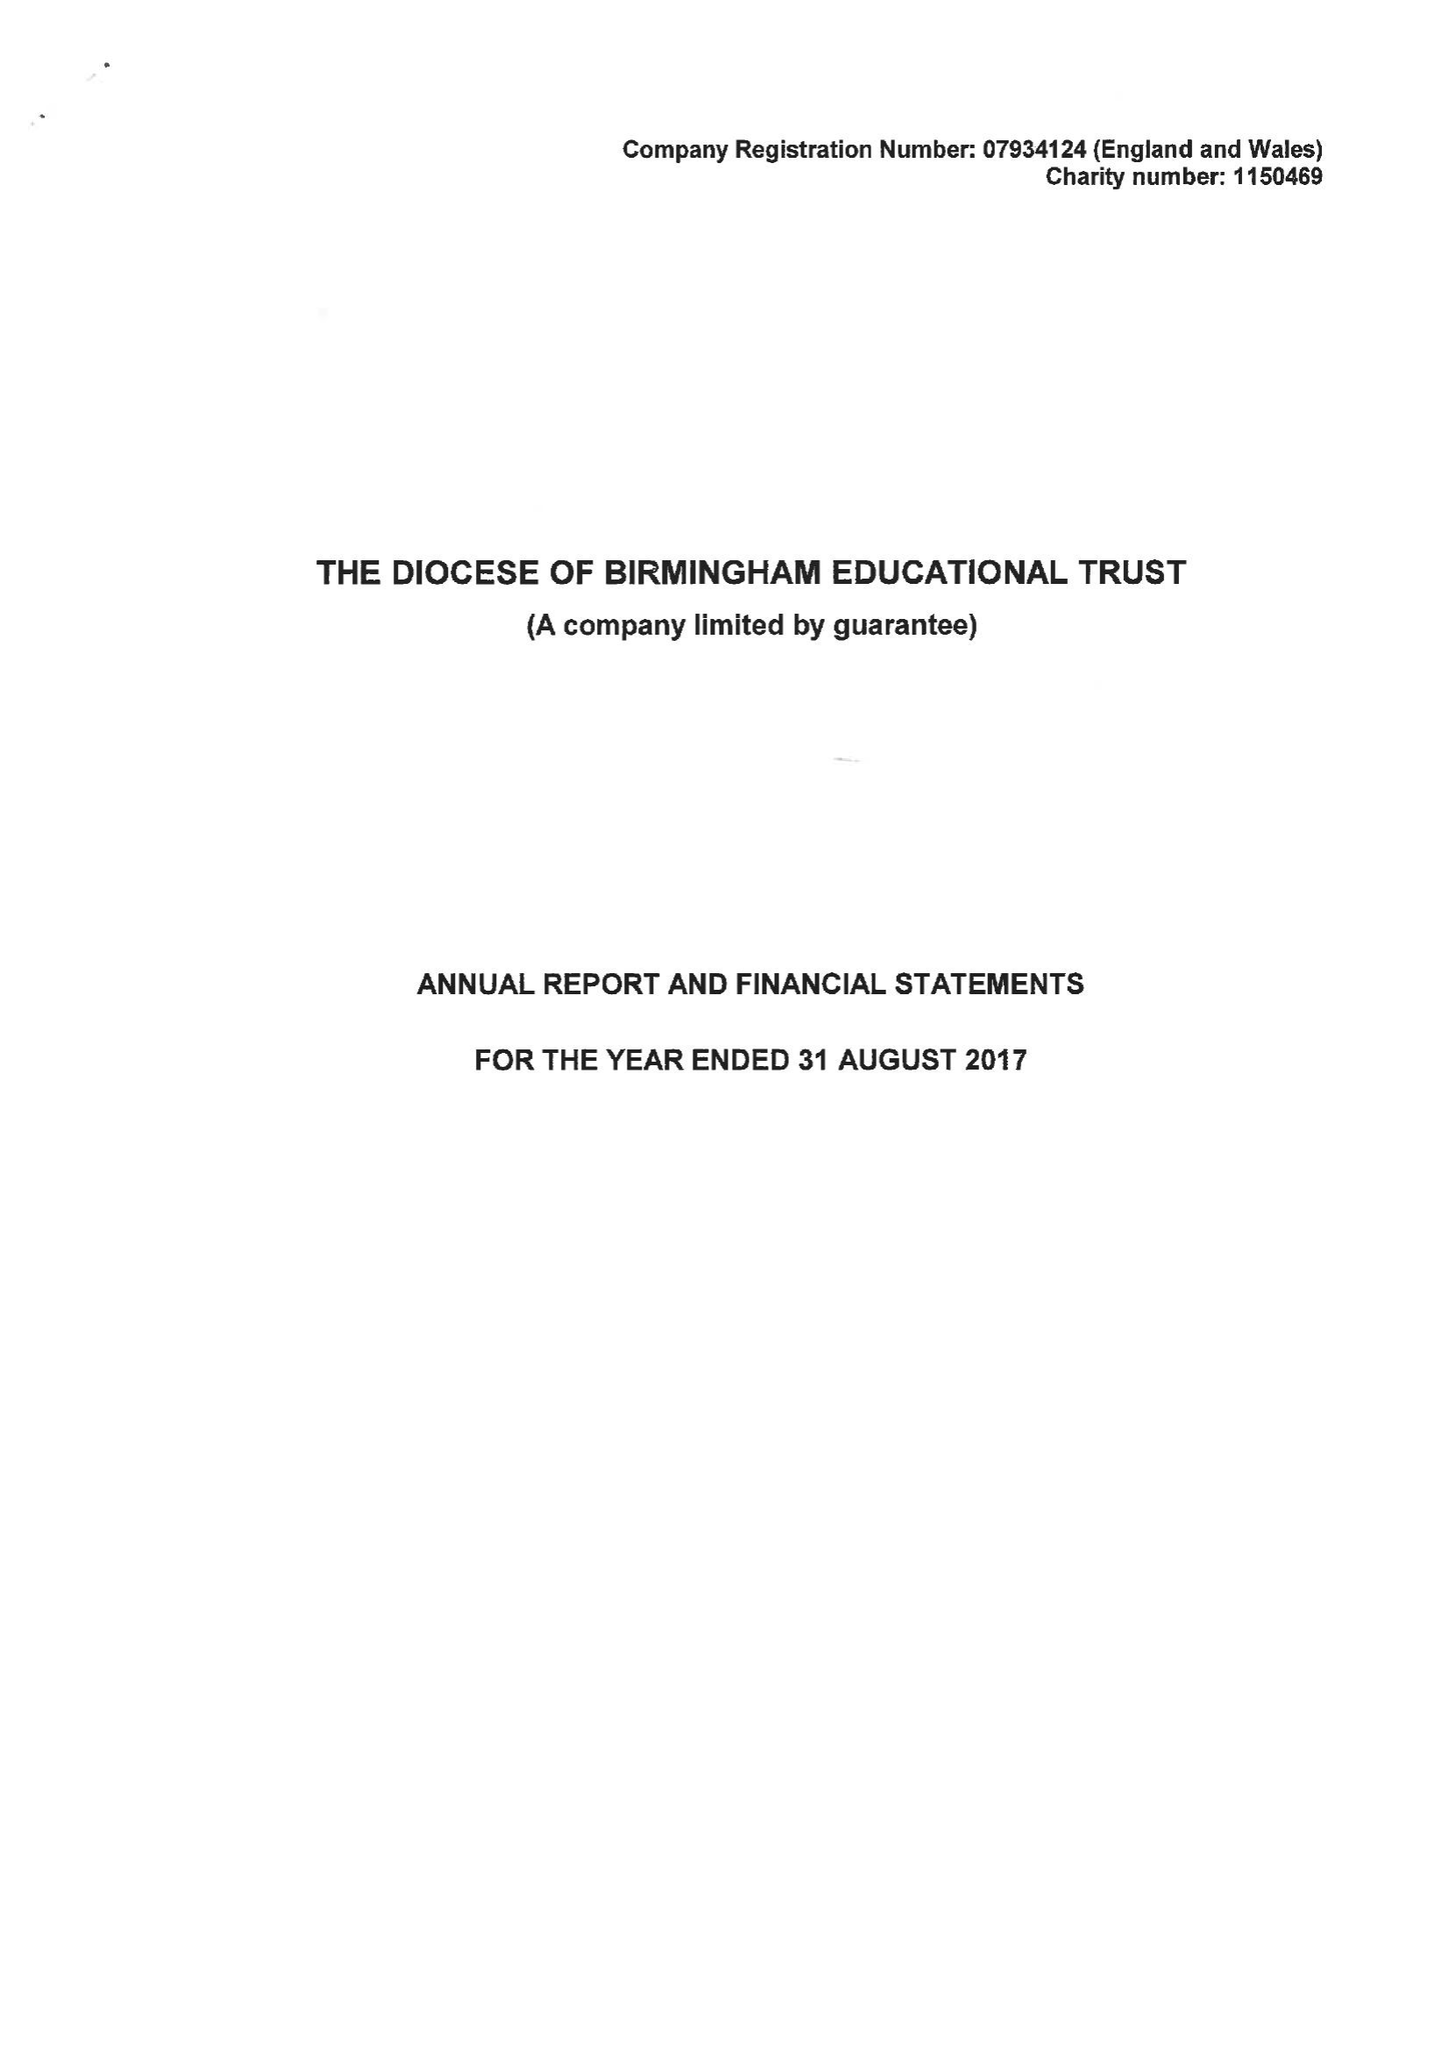What is the value for the address__postcode?
Answer the question using a single word or phrase. B3 2BJ 